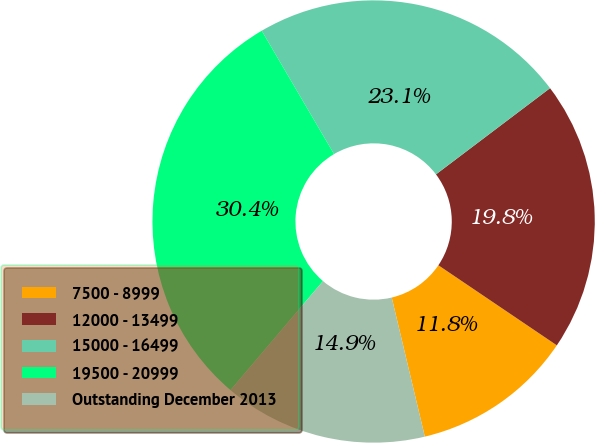Convert chart to OTSL. <chart><loc_0><loc_0><loc_500><loc_500><pie_chart><fcel>7500 - 8999<fcel>12000 - 13499<fcel>15000 - 16499<fcel>19500 - 20999<fcel>Outstanding December 2013<nl><fcel>11.82%<fcel>19.76%<fcel>23.14%<fcel>30.36%<fcel>14.92%<nl></chart> 